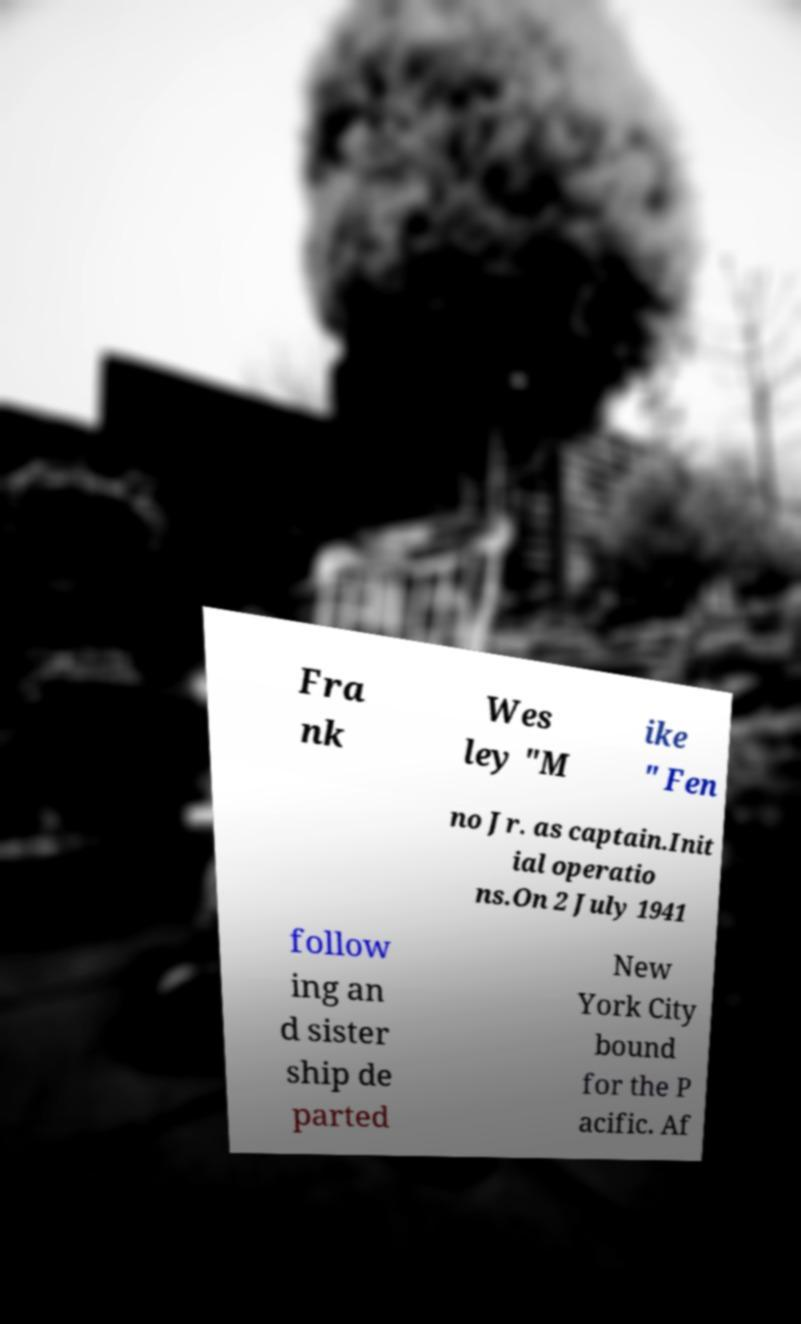Can you accurately transcribe the text from the provided image for me? Fra nk Wes ley "M ike " Fen no Jr. as captain.Init ial operatio ns.On 2 July 1941 follow ing an d sister ship de parted New York City bound for the P acific. Af 